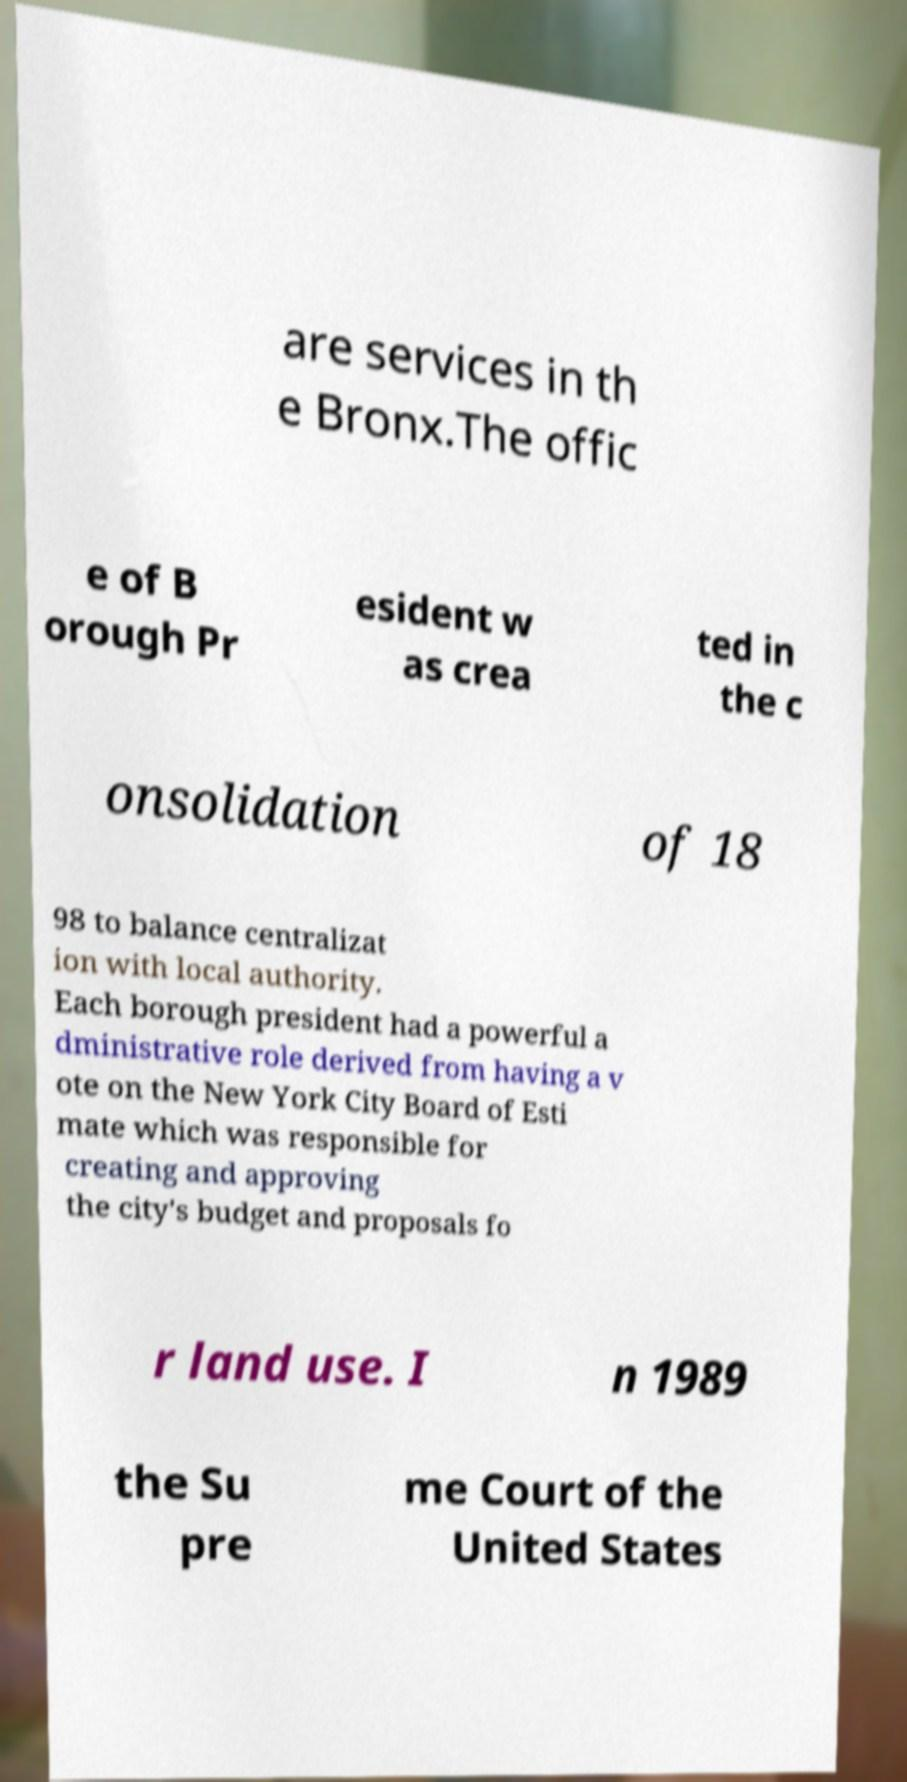Can you accurately transcribe the text from the provided image for me? are services in th e Bronx.The offic e of B orough Pr esident w as crea ted in the c onsolidation of 18 98 to balance centralizat ion with local authority. Each borough president had a powerful a dministrative role derived from having a v ote on the New York City Board of Esti mate which was responsible for creating and approving the city's budget and proposals fo r land use. I n 1989 the Su pre me Court of the United States 